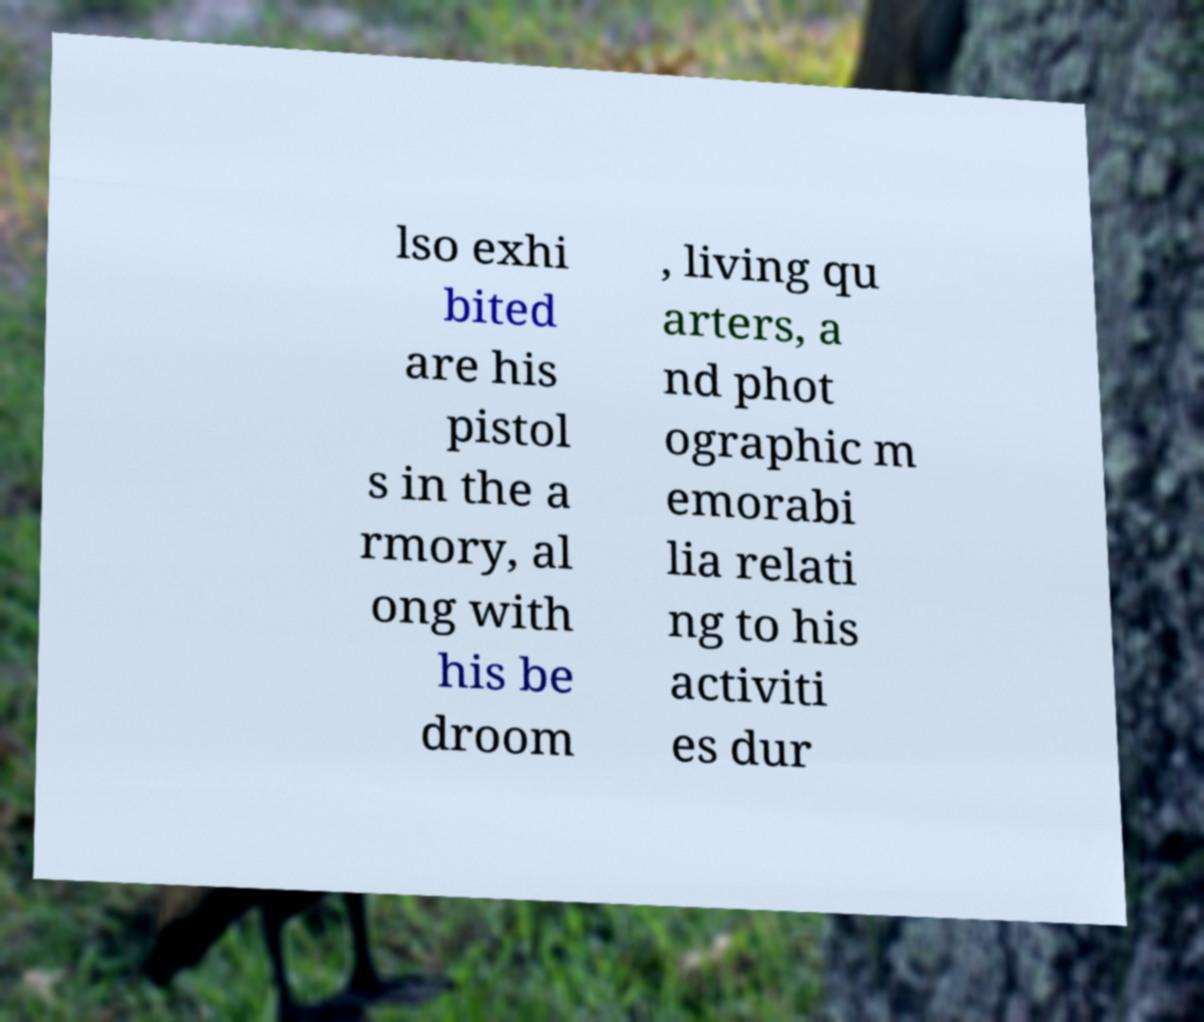Please read and relay the text visible in this image. What does it say? lso exhi bited are his pistol s in the a rmory, al ong with his be droom , living qu arters, a nd phot ographic m emorabi lia relati ng to his activiti es dur 